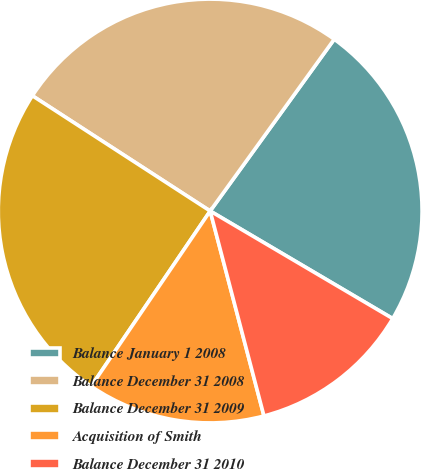<chart> <loc_0><loc_0><loc_500><loc_500><pie_chart><fcel>Balance January 1 2008<fcel>Balance December 31 2008<fcel>Balance December 31 2009<fcel>Acquisition of Smith<fcel>Balance December 31 2010<nl><fcel>23.52%<fcel>25.8%<fcel>24.66%<fcel>13.58%<fcel>12.44%<nl></chart> 